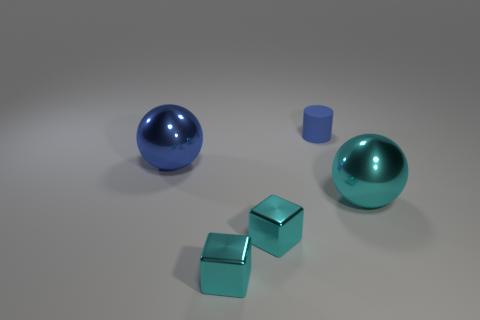Add 1 tiny cyan matte cubes. How many objects exist? 6 Subtract all spheres. How many objects are left? 3 Subtract all red cubes. Subtract all red cylinders. How many cubes are left? 2 Subtract all cyan balls. How many purple cylinders are left? 0 Subtract all big red rubber things. Subtract all tiny objects. How many objects are left? 2 Add 5 big spheres. How many big spheres are left? 7 Add 5 cyan spheres. How many cyan spheres exist? 6 Subtract 0 brown spheres. How many objects are left? 5 